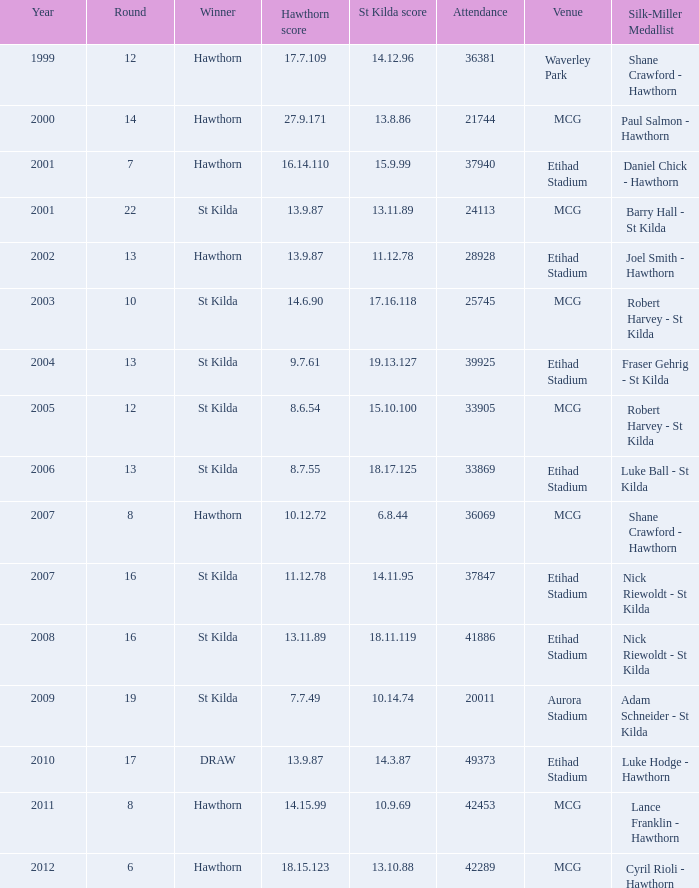What is the attendance when the hawthorn score is 18.15.123? 42289.0. 